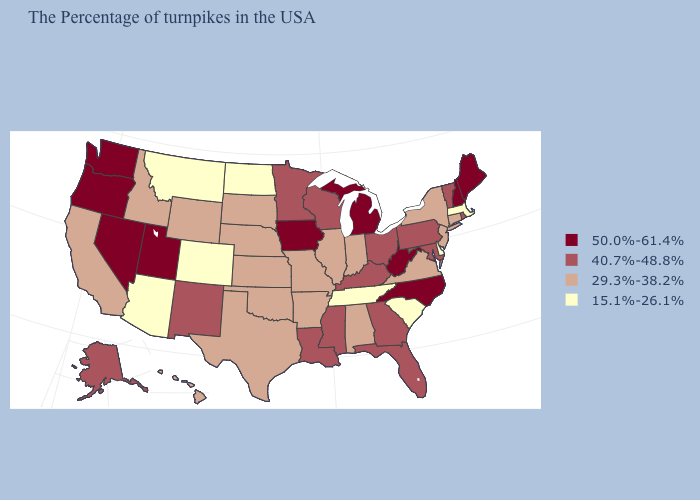Name the states that have a value in the range 15.1%-26.1%?
Answer briefly. Massachusetts, Delaware, South Carolina, Tennessee, North Dakota, Colorado, Montana, Arizona. Does West Virginia have the highest value in the USA?
Quick response, please. Yes. Does the map have missing data?
Quick response, please. No. Which states have the lowest value in the MidWest?
Be succinct. North Dakota. What is the value of Wisconsin?
Concise answer only. 40.7%-48.8%. What is the highest value in the MidWest ?
Quick response, please. 50.0%-61.4%. Does Kansas have the lowest value in the USA?
Give a very brief answer. No. Does the first symbol in the legend represent the smallest category?
Concise answer only. No. Does the map have missing data?
Give a very brief answer. No. Which states have the lowest value in the Northeast?
Give a very brief answer. Massachusetts. What is the value of Delaware?
Short answer required. 15.1%-26.1%. Does North Carolina have the highest value in the South?
Write a very short answer. Yes. Name the states that have a value in the range 29.3%-38.2%?
Give a very brief answer. Connecticut, New York, New Jersey, Virginia, Indiana, Alabama, Illinois, Missouri, Arkansas, Kansas, Nebraska, Oklahoma, Texas, South Dakota, Wyoming, Idaho, California, Hawaii. Is the legend a continuous bar?
Concise answer only. No. What is the value of New Jersey?
Answer briefly. 29.3%-38.2%. 